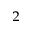Convert formula to latex. <formula><loc_0><loc_0><loc_500><loc_500>^ { 2 }</formula> 